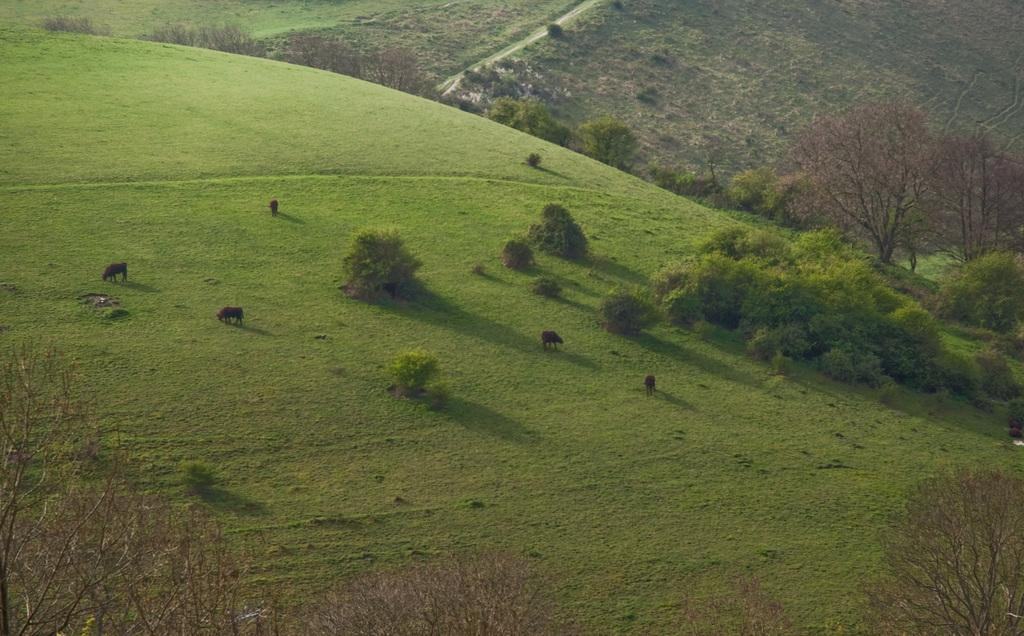What type of vegetation is in the center of the image? There is grass in the center of the image. What other living organisms can be seen in the image? There are animals in the image. What type of plants are present in the image? There are trees in the image. Where are the trees located in the image? There are trees at the bottom of the image. What can be seen in the background of the image? There is a road visible in the background of the image. How many apples are being held by the babies in the image? There are no babies or apples present in the image. What type of train can be seen passing through the trees in the image? There is no train visible in the image; only a road can be seen in the background. 